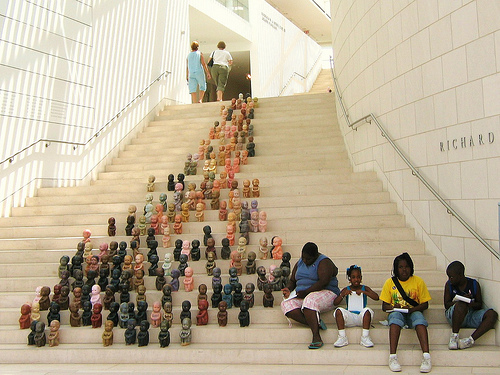<image>
Is the stairs above the person? Yes. The stairs is positioned above the person in the vertical space, higher up in the scene. 